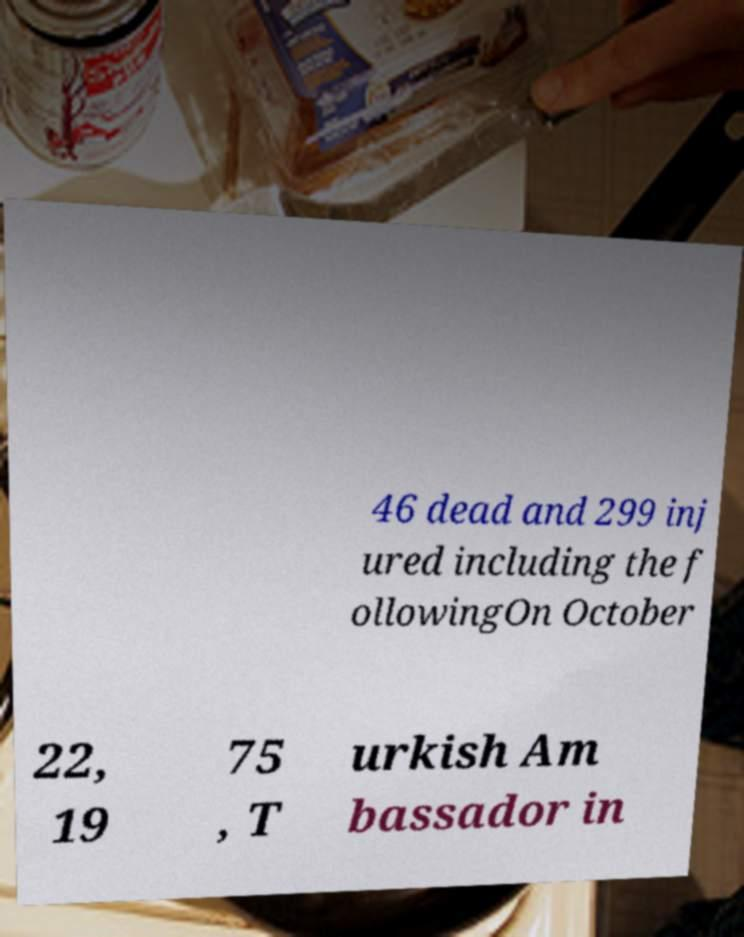Please read and relay the text visible in this image. What does it say? 46 dead and 299 inj ured including the f ollowingOn October 22, 19 75 , T urkish Am bassador in 